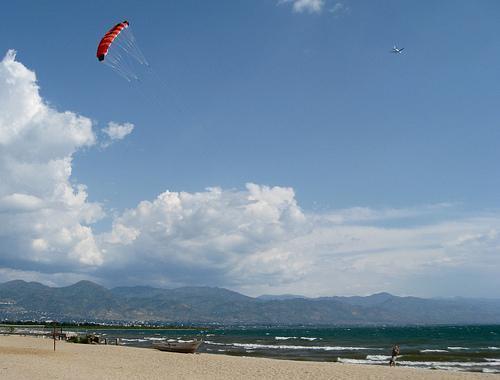How many boats are there?
Give a very brief answer. 1. 